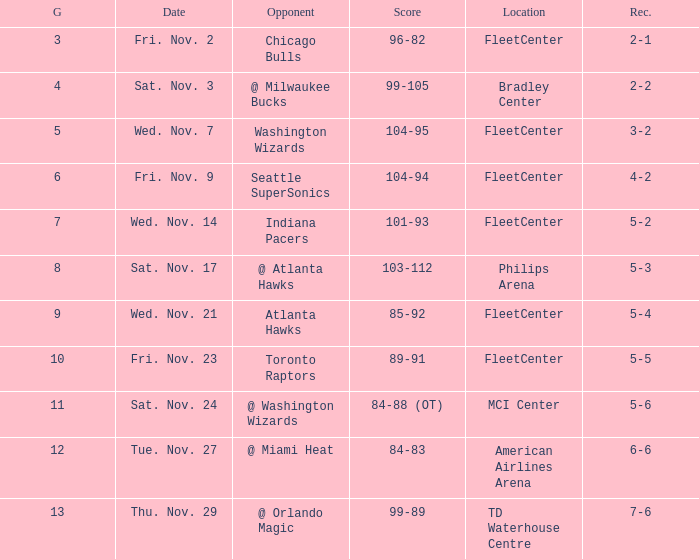What is the earliest game with a score of 99-89? 13.0. 